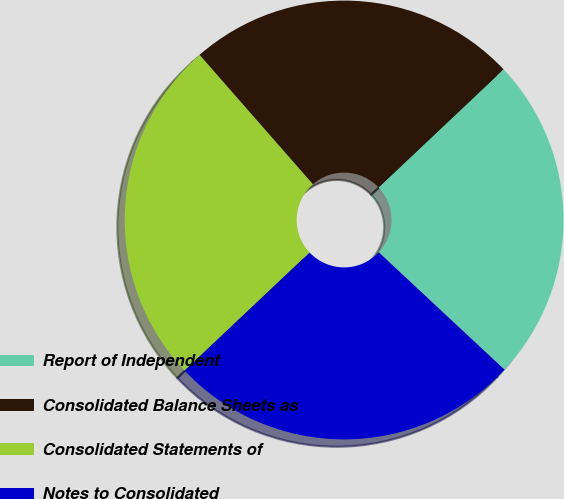<chart> <loc_0><loc_0><loc_500><loc_500><pie_chart><fcel>Report of Independent<fcel>Consolidated Balance Sheets as<fcel>Consolidated Statements of<fcel>Notes to Consolidated<nl><fcel>24.0%<fcel>24.4%<fcel>25.6%<fcel>26.0%<nl></chart> 